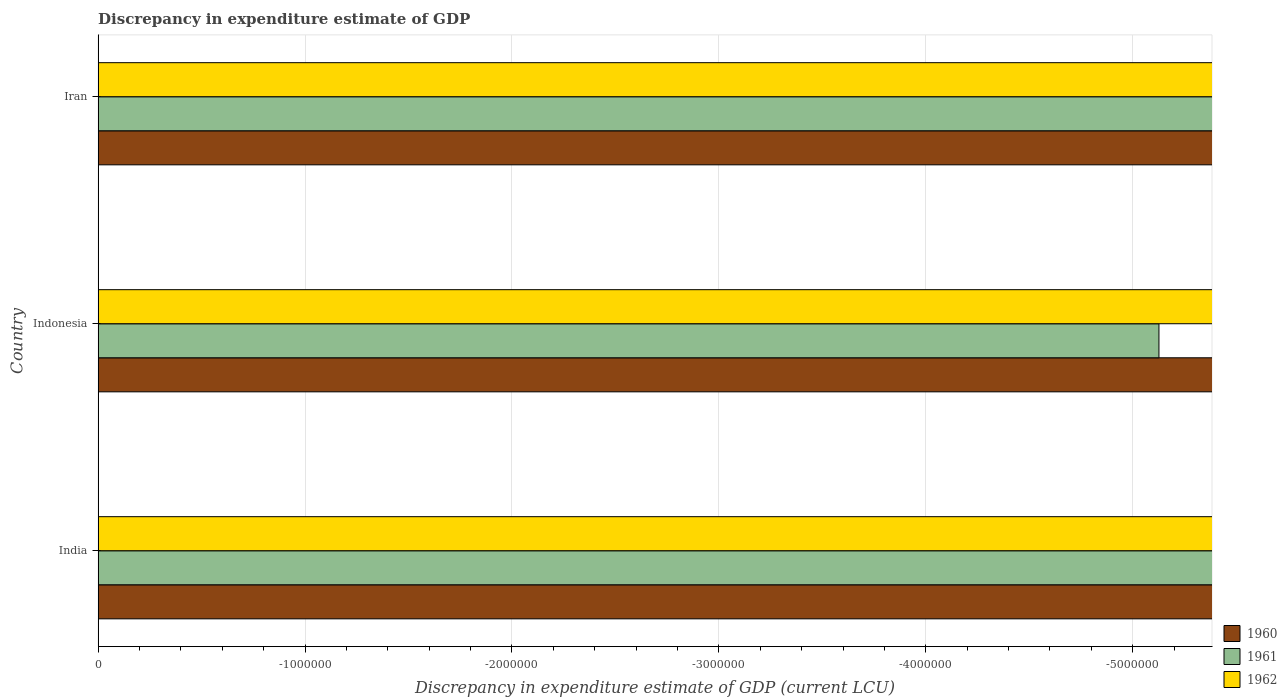Are the number of bars per tick equal to the number of legend labels?
Offer a terse response. No. How many bars are there on the 2nd tick from the bottom?
Provide a short and direct response. 0. What is the discrepancy in expenditure estimate of GDP in 1961 in India?
Your answer should be compact. 0. Across all countries, what is the minimum discrepancy in expenditure estimate of GDP in 1962?
Provide a short and direct response. 0. What is the total discrepancy in expenditure estimate of GDP in 1962 in the graph?
Keep it short and to the point. 0. What is the difference between the discrepancy in expenditure estimate of GDP in 1962 in India and the discrepancy in expenditure estimate of GDP in 1960 in Indonesia?
Offer a terse response. 0. What is the average discrepancy in expenditure estimate of GDP in 1961 per country?
Make the answer very short. 0. In how many countries, is the discrepancy in expenditure estimate of GDP in 1962 greater than the average discrepancy in expenditure estimate of GDP in 1962 taken over all countries?
Your response must be concise. 0. Is it the case that in every country, the sum of the discrepancy in expenditure estimate of GDP in 1961 and discrepancy in expenditure estimate of GDP in 1962 is greater than the discrepancy in expenditure estimate of GDP in 1960?
Offer a terse response. No. How many bars are there?
Give a very brief answer. 0. How many countries are there in the graph?
Make the answer very short. 3. What is the difference between two consecutive major ticks on the X-axis?
Make the answer very short. 1.00e+06. How many legend labels are there?
Give a very brief answer. 3. What is the title of the graph?
Give a very brief answer. Discrepancy in expenditure estimate of GDP. What is the label or title of the X-axis?
Your answer should be compact. Discrepancy in expenditure estimate of GDP (current LCU). What is the Discrepancy in expenditure estimate of GDP (current LCU) of 1961 in India?
Keep it short and to the point. 0. What is the Discrepancy in expenditure estimate of GDP (current LCU) of 1962 in India?
Ensure brevity in your answer.  0. What is the Discrepancy in expenditure estimate of GDP (current LCU) in 1960 in Iran?
Your response must be concise. 0. What is the average Discrepancy in expenditure estimate of GDP (current LCU) in 1960 per country?
Your answer should be very brief. 0. 